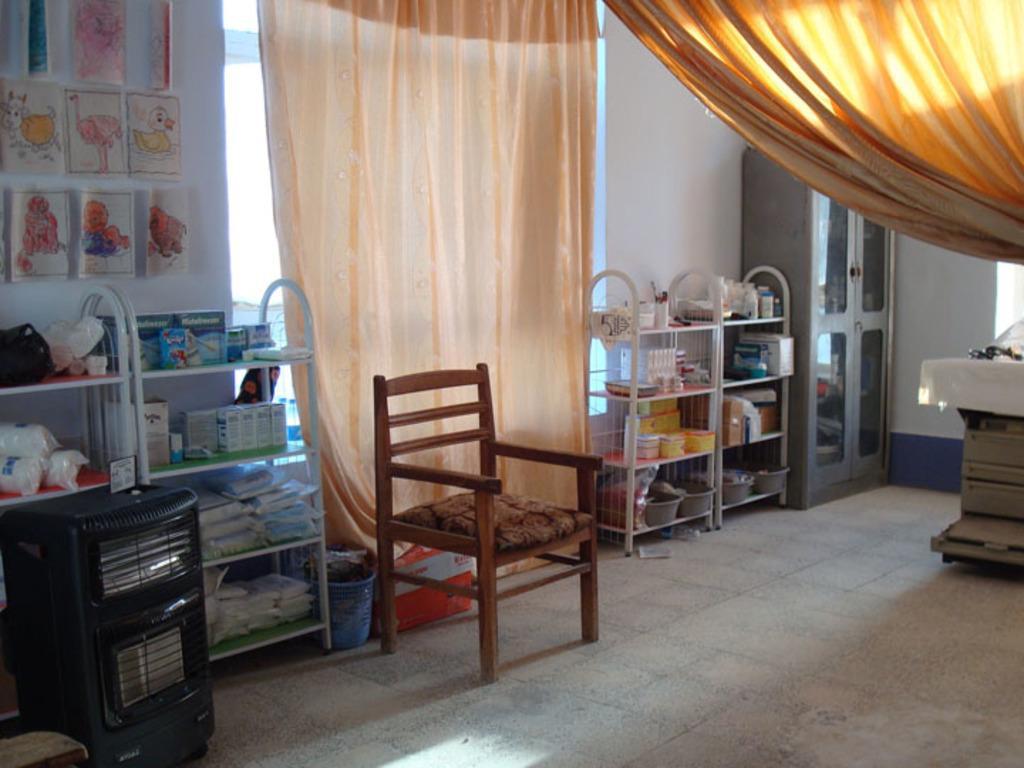Can you describe this image briefly? Here in this picture we can see a chair present on the floor and we can also see some racks with number of things present on it over there and beside that we can see an cup board present and on the wall we can see drawings present and we can see curtains present over there. 